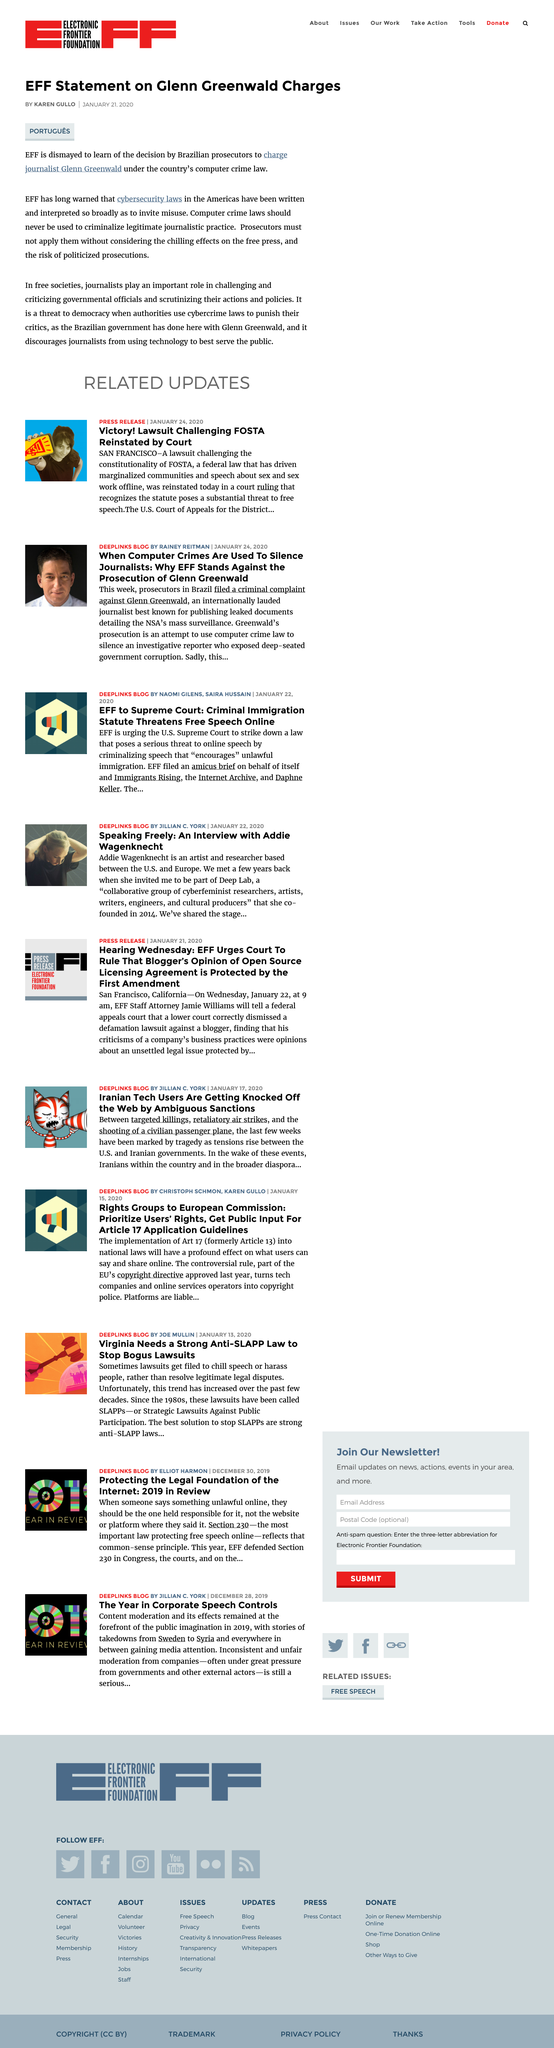Identify some key points in this picture. Glen Greenwald is a journalist. Glen Greenwald is being prosecuted by the Brazilian authorities. 